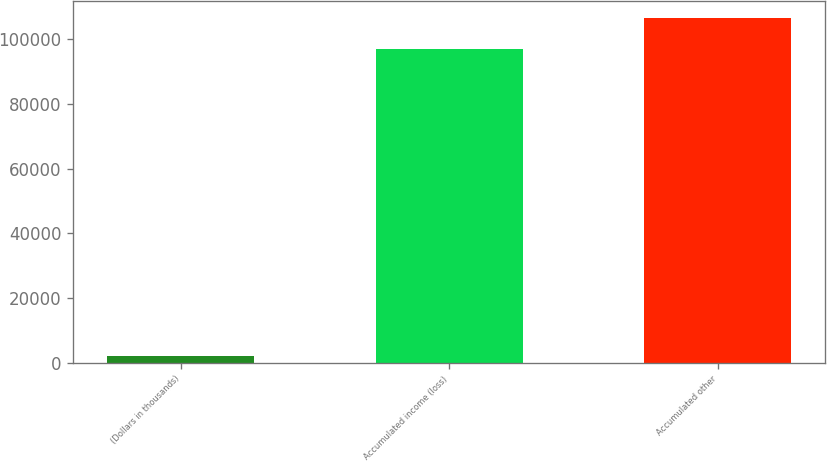<chart> <loc_0><loc_0><loc_500><loc_500><bar_chart><fcel>(Dollars in thousands)<fcel>Accumulated income (loss)<fcel>Accumulated other<nl><fcel>2016<fcel>96965<fcel>106460<nl></chart> 